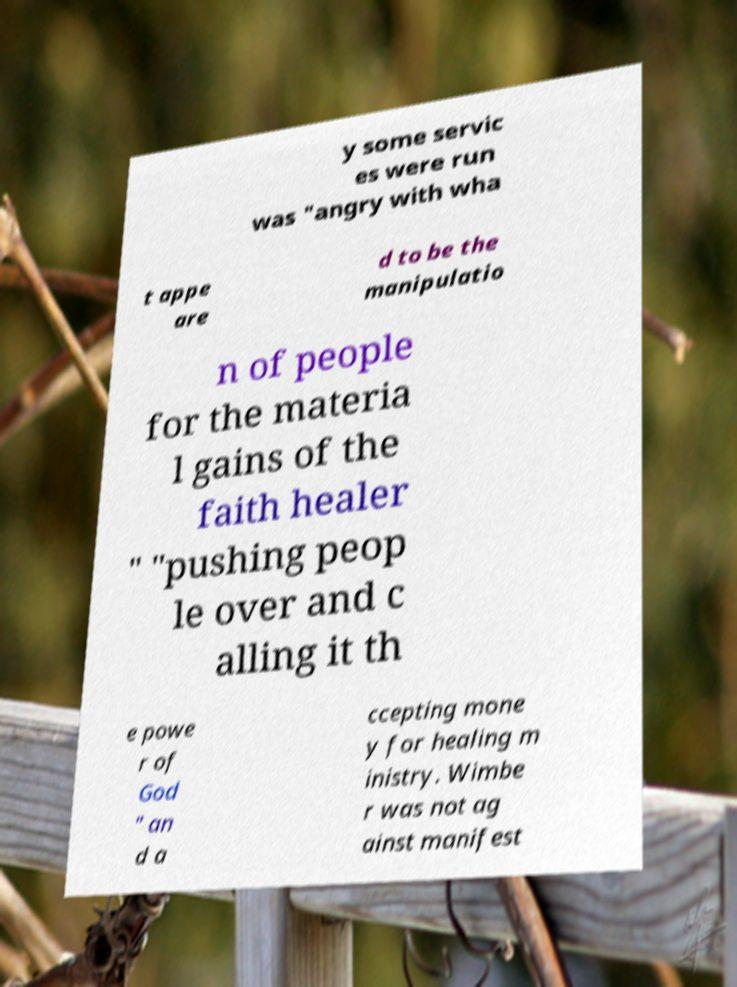I need the written content from this picture converted into text. Can you do that? y some servic es were run was "angry with wha t appe are d to be the manipulatio n of people for the materia l gains of the faith healer " "pushing peop le over and c alling it th e powe r of God " an d a ccepting mone y for healing m inistry. Wimbe r was not ag ainst manifest 